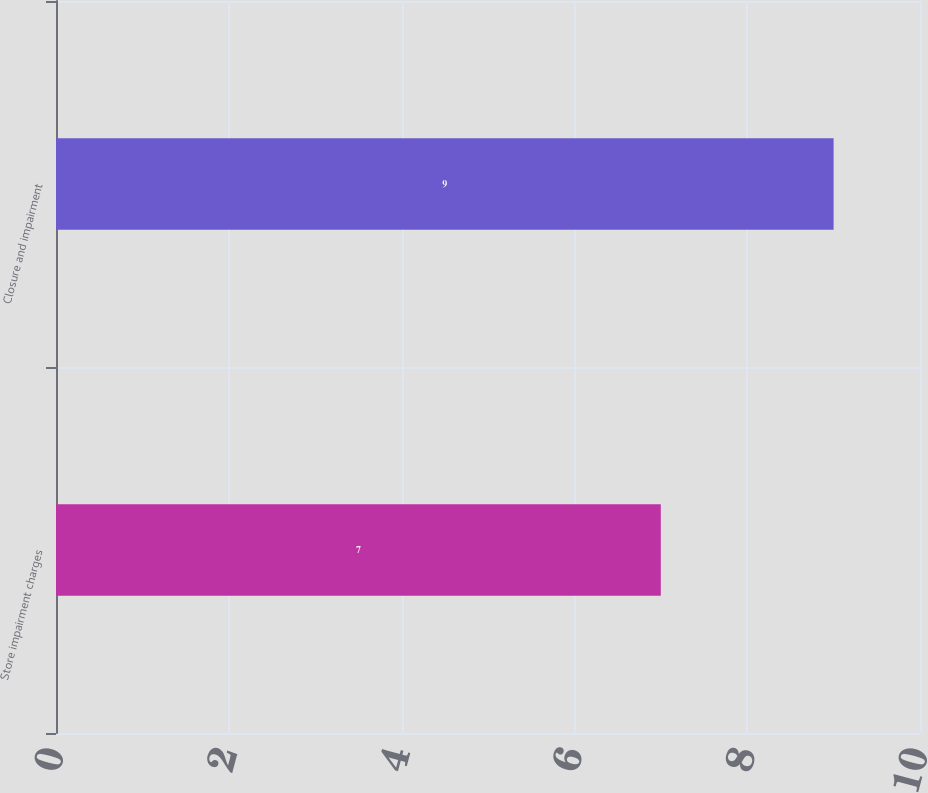Convert chart. <chart><loc_0><loc_0><loc_500><loc_500><bar_chart><fcel>Store impairment charges<fcel>Closure and impairment<nl><fcel>7<fcel>9<nl></chart> 